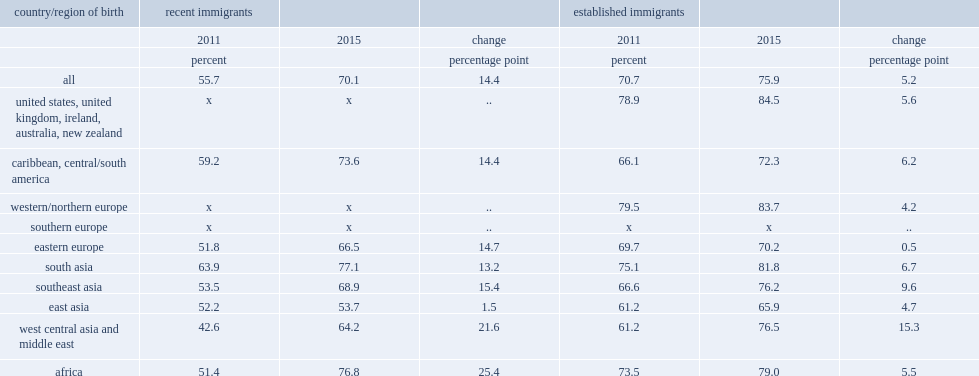Between 2011 and 2015, which type's voting rate increased faster? Recent immigrants. What was the voting rate of recent immigrants from africa increased by? 25.4. What was the rate for recent immigrants from west central asia and the middle east increased by? 21.6. 